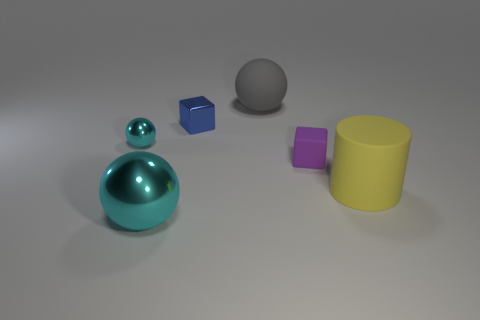How many other things are the same size as the gray object? There are two objects that appear to be roughly the same size as the gray sphere: the blue cube and the purple cube. 